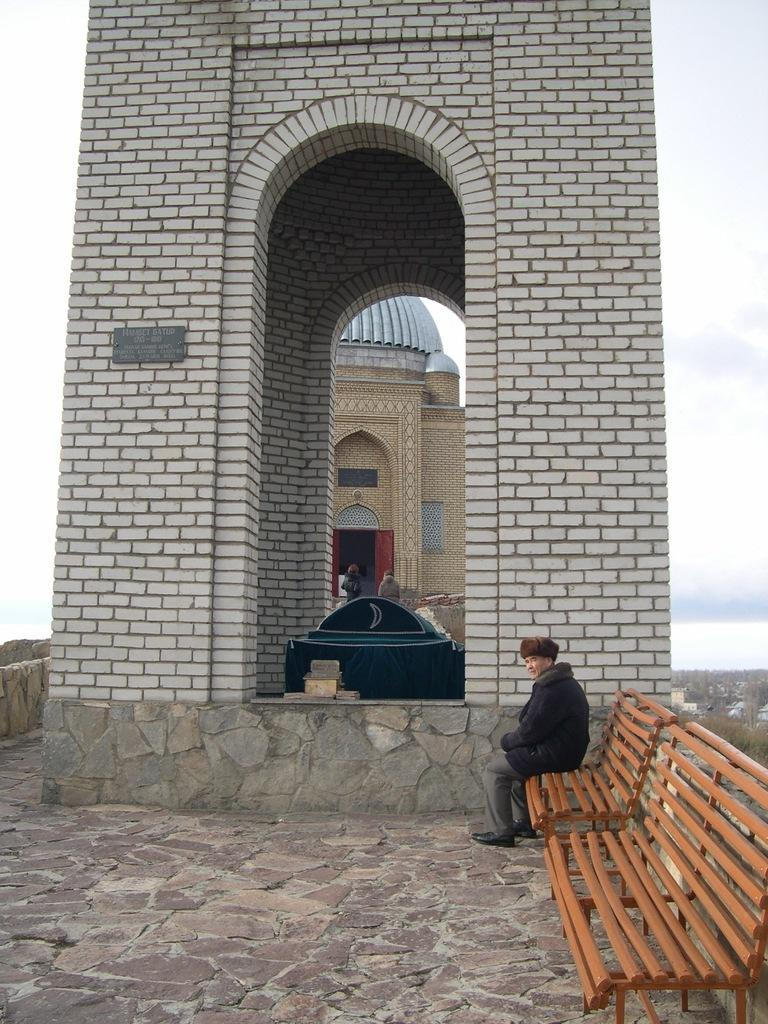What is the person in the image doing? The person is sitting on a bench in the image. What color is the bench? The bench is brown. What can be seen in the background of the image? There is a building in the background of the image. Reasoning: Let'g: Let's think step by step in order to produce the conversation. We start by identifying the main subject in the image, which is the person sitting on the bench. Then, we describe the bench's color, which is brown. Finally, we mention the background of the image, which includes a building. Each question is designed to elicit a specific detail about the image that is known from the provided facts. Absurd Question/Answer: What type of linen is draped over the person's foot in the image? There is no linen or foot mentioned in the image; it only describes a person sitting on a brown bench with a building in the background. Are there any goldfish swimming in the water near the bench in the image? There is no water or goldfish mentioned in the image; it only describes a person sitting on a brown bench with a building in the background. 